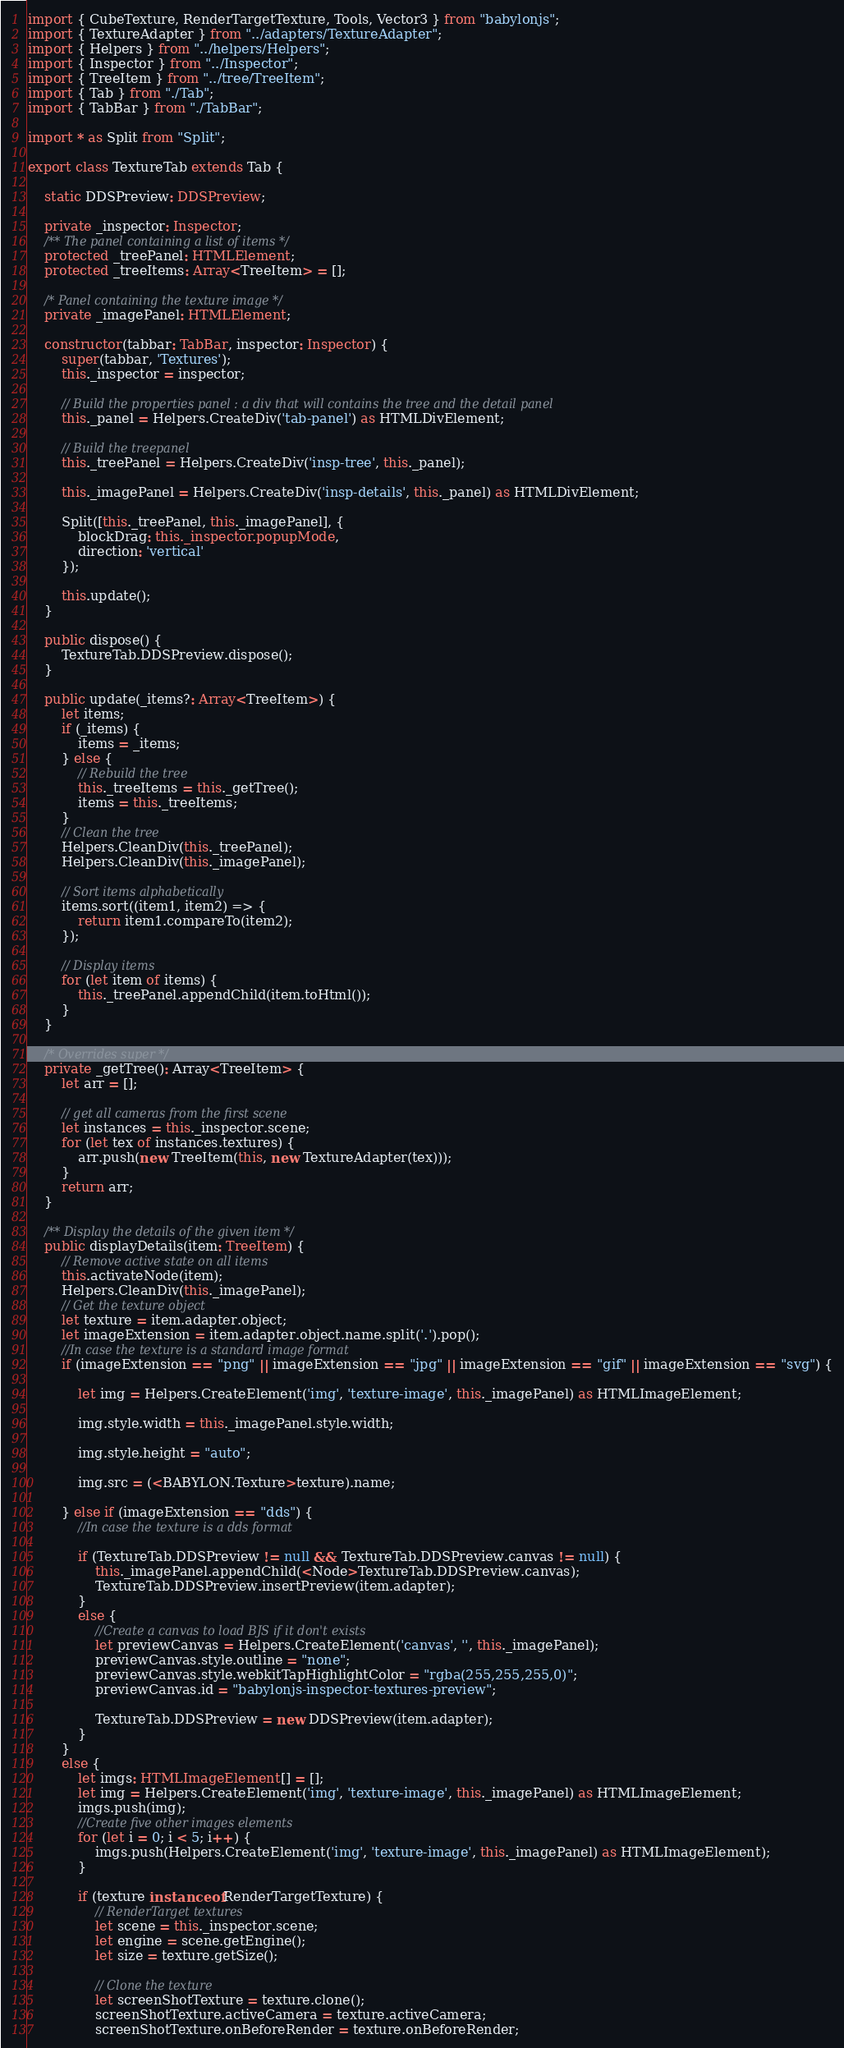<code> <loc_0><loc_0><loc_500><loc_500><_TypeScript_>import { CubeTexture, RenderTargetTexture, Tools, Vector3 } from "babylonjs";
import { TextureAdapter } from "../adapters/TextureAdapter";
import { Helpers } from "../helpers/Helpers";
import { Inspector } from "../Inspector";
import { TreeItem } from "../tree/TreeItem";
import { Tab } from "./Tab";
import { TabBar } from "./TabBar";

import * as Split from "Split";

export class TextureTab extends Tab {

    static DDSPreview: DDSPreview;

    private _inspector: Inspector;
    /** The panel containing a list of items */
    protected _treePanel: HTMLElement;
    protected _treeItems: Array<TreeItem> = [];

    /* Panel containing the texture image */
    private _imagePanel: HTMLElement;

    constructor(tabbar: TabBar, inspector: Inspector) {
        super(tabbar, 'Textures');
        this._inspector = inspector;

        // Build the properties panel : a div that will contains the tree and the detail panel
        this._panel = Helpers.CreateDiv('tab-panel') as HTMLDivElement;

        // Build the treepanel
        this._treePanel = Helpers.CreateDiv('insp-tree', this._panel);

        this._imagePanel = Helpers.CreateDiv('insp-details', this._panel) as HTMLDivElement;

        Split([this._treePanel, this._imagePanel], {
            blockDrag: this._inspector.popupMode,
            direction: 'vertical'
        });

        this.update();
    }

    public dispose() {
        TextureTab.DDSPreview.dispose();
    }

    public update(_items?: Array<TreeItem>) {
        let items;
        if (_items) {
            items = _items;
        } else {
            // Rebuild the tree
            this._treeItems = this._getTree();
            items = this._treeItems;
        }
        // Clean the tree
        Helpers.CleanDiv(this._treePanel);
        Helpers.CleanDiv(this._imagePanel);

        // Sort items alphabetically
        items.sort((item1, item2) => {
            return item1.compareTo(item2);
        });

        // Display items
        for (let item of items) {
            this._treePanel.appendChild(item.toHtml());
        }
    }

    /* Overrides super */
    private _getTree(): Array<TreeItem> {
        let arr = [];

        // get all cameras from the first scene
        let instances = this._inspector.scene;
        for (let tex of instances.textures) {
            arr.push(new TreeItem(this, new TextureAdapter(tex)));
        }
        return arr;
    }

    /** Display the details of the given item */
    public displayDetails(item: TreeItem) {
        // Remove active state on all items
        this.activateNode(item);
        Helpers.CleanDiv(this._imagePanel);
        // Get the texture object
        let texture = item.adapter.object;
        let imageExtension = item.adapter.object.name.split('.').pop();
        //In case the texture is a standard image format
        if (imageExtension == "png" || imageExtension == "jpg" || imageExtension == "gif" || imageExtension == "svg") {

            let img = Helpers.CreateElement('img', 'texture-image', this._imagePanel) as HTMLImageElement;

            img.style.width = this._imagePanel.style.width;

            img.style.height = "auto";

            img.src = (<BABYLON.Texture>texture).name;

        } else if (imageExtension == "dds") {
            //In case the texture is a dds format

            if (TextureTab.DDSPreview != null && TextureTab.DDSPreview.canvas != null) {
                this._imagePanel.appendChild(<Node>TextureTab.DDSPreview.canvas);
                TextureTab.DDSPreview.insertPreview(item.adapter);
            }
            else {
                //Create a canvas to load BJS if it don't exists
                let previewCanvas = Helpers.CreateElement('canvas', '', this._imagePanel);
                previewCanvas.style.outline = "none";
                previewCanvas.style.webkitTapHighlightColor = "rgba(255,255,255,0)";
                previewCanvas.id = "babylonjs-inspector-textures-preview";

                TextureTab.DDSPreview = new DDSPreview(item.adapter);
            }
        }
        else {
            let imgs: HTMLImageElement[] = [];
            let img = Helpers.CreateElement('img', 'texture-image', this._imagePanel) as HTMLImageElement;
            imgs.push(img);
            //Create five other images elements
            for (let i = 0; i < 5; i++) {
                imgs.push(Helpers.CreateElement('img', 'texture-image', this._imagePanel) as HTMLImageElement);
            }

            if (texture instanceof RenderTargetTexture) {
                // RenderTarget textures
                let scene = this._inspector.scene;
                let engine = scene.getEngine();
                let size = texture.getSize();

                // Clone the texture
                let screenShotTexture = texture.clone();
                screenShotTexture.activeCamera = texture.activeCamera;
                screenShotTexture.onBeforeRender = texture.onBeforeRender;</code> 